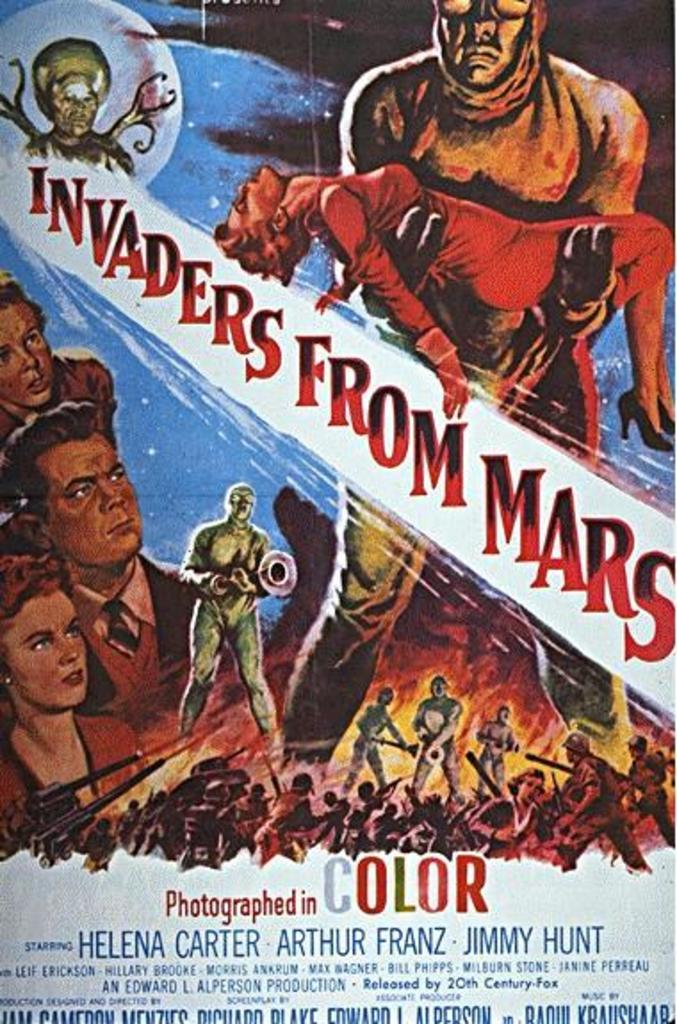<image>
Relay a brief, clear account of the picture shown. A movie poster advertises Invaders from Mars in color. 